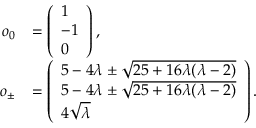Convert formula to latex. <formula><loc_0><loc_0><loc_500><loc_500>\begin{array} { r l } { o _ { 0 } } & { = \left ( \begin{array} { l } { 1 } \\ { - 1 } \\ { 0 } \end{array} \right ) , } \\ { o _ { \pm } } & { = \left ( \begin{array} { l } { 5 - 4 \lambda \pm \sqrt { 2 5 + 1 6 \lambda ( \lambda - 2 ) } } \\ { 5 - 4 \lambda \pm \sqrt { 2 5 + 1 6 \lambda ( \lambda - 2 ) } } \\ { 4 \sqrt { \lambda } } \end{array} \right ) . } \end{array}</formula> 